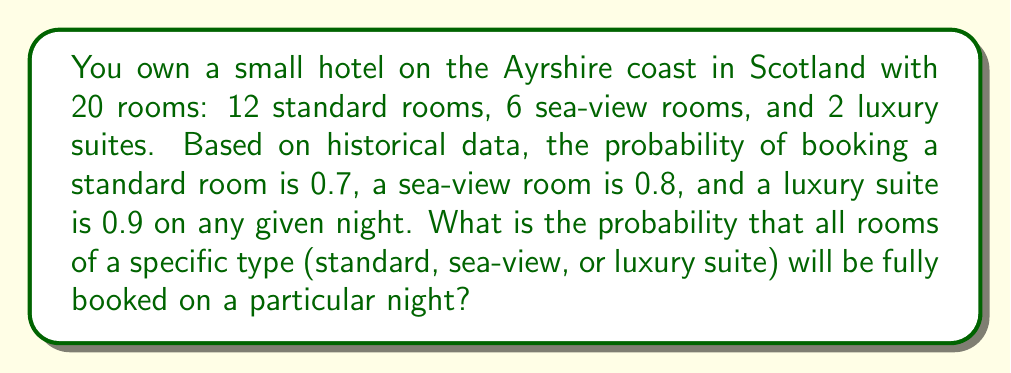Teach me how to tackle this problem. To solve this problem, we need to calculate the probability of fully booking each room type separately. We'll use the binomial probability formula for each case.

The probability of exactly $k$ successes in $n$ trials is given by:

$$ P(X = k) = \binom{n}{k} p^k (1-p)^{n-k} $$

where $n$ is the number of trials, $k$ is the number of successes, $p$ is the probability of success on a single trial.

1. For standard rooms:
   $n = 12$, $k = 12$, $p = 0.7$
   $$ P(\text{all standard rooms booked}) = \binom{12}{12} 0.7^{12} (1-0.7)^{12-12} = 0.7^{12} \approx 0.0138 $$

2. For sea-view rooms:
   $n = 6$, $k = 6$, $p = 0.8$
   $$ P(\text{all sea-view rooms booked}) = \binom{6}{6} 0.8^6 (1-0.8)^{6-6} = 0.8^6 \approx 0.2621 $$

3. For luxury suites:
   $n = 2$, $k = 2$, $p = 0.9$
   $$ P(\text{all luxury suites booked}) = \binom{2}{2} 0.9^2 (1-0.9)^{2-2} = 0.9^2 = 0.81 $$

The probability of fully booking a specific room type is the highest for luxury suites, followed by sea-view rooms, and then standard rooms.
Answer: The probabilities of fully booking specific room types are:
Standard rooms: $\approx 0.0138$ or $1.38\%$
Sea-view rooms: $\approx 0.2621$ or $26.21\%$
Luxury suites: $0.81$ or $81\%$ 